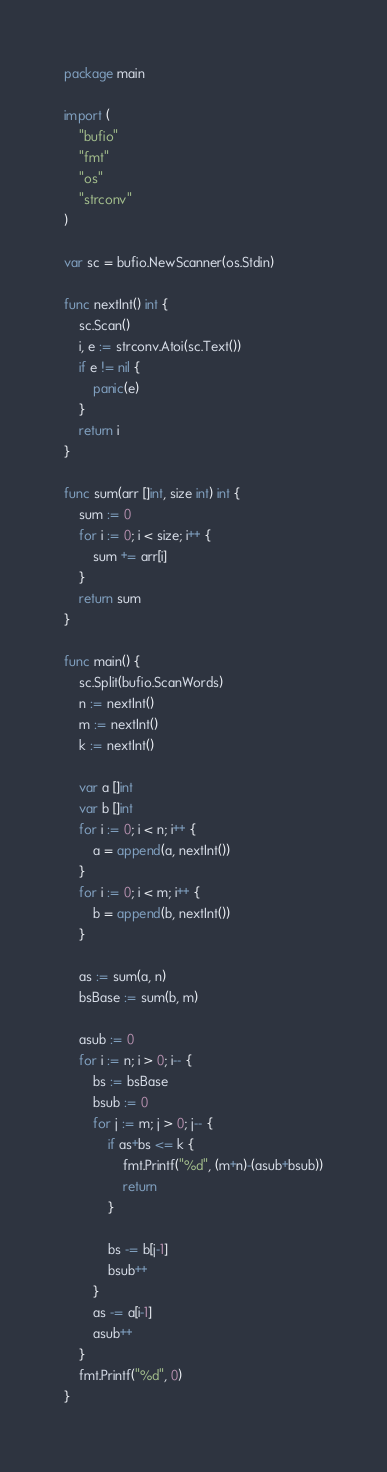<code> <loc_0><loc_0><loc_500><loc_500><_Go_>package main

import (
	"bufio"
	"fmt"
	"os"
	"strconv"
)

var sc = bufio.NewScanner(os.Stdin)

func nextInt() int {
	sc.Scan()
	i, e := strconv.Atoi(sc.Text())
	if e != nil {
		panic(e)
	}
	return i
}

func sum(arr []int, size int) int {
	sum := 0
	for i := 0; i < size; i++ {
		sum += arr[i]
	}
	return sum
}

func main() {
	sc.Split(bufio.ScanWords)
	n := nextInt()
	m := nextInt()
	k := nextInt()

	var a []int
	var b []int
	for i := 0; i < n; i++ {
		a = append(a, nextInt())
	}
	for i := 0; i < m; i++ {
		b = append(b, nextInt())
	}

	as := sum(a, n)
	bsBase := sum(b, m)

	asub := 0
	for i := n; i > 0; i-- {
		bs := bsBase
		bsub := 0
		for j := m; j > 0; j-- {
			if as+bs <= k {
				fmt.Printf("%d", (m+n)-(asub+bsub))
				return
			}

			bs -= b[j-1]
			bsub++
		}
		as -= a[i-1]
		asub++
	}
	fmt.Printf("%d", 0)
}
</code> 